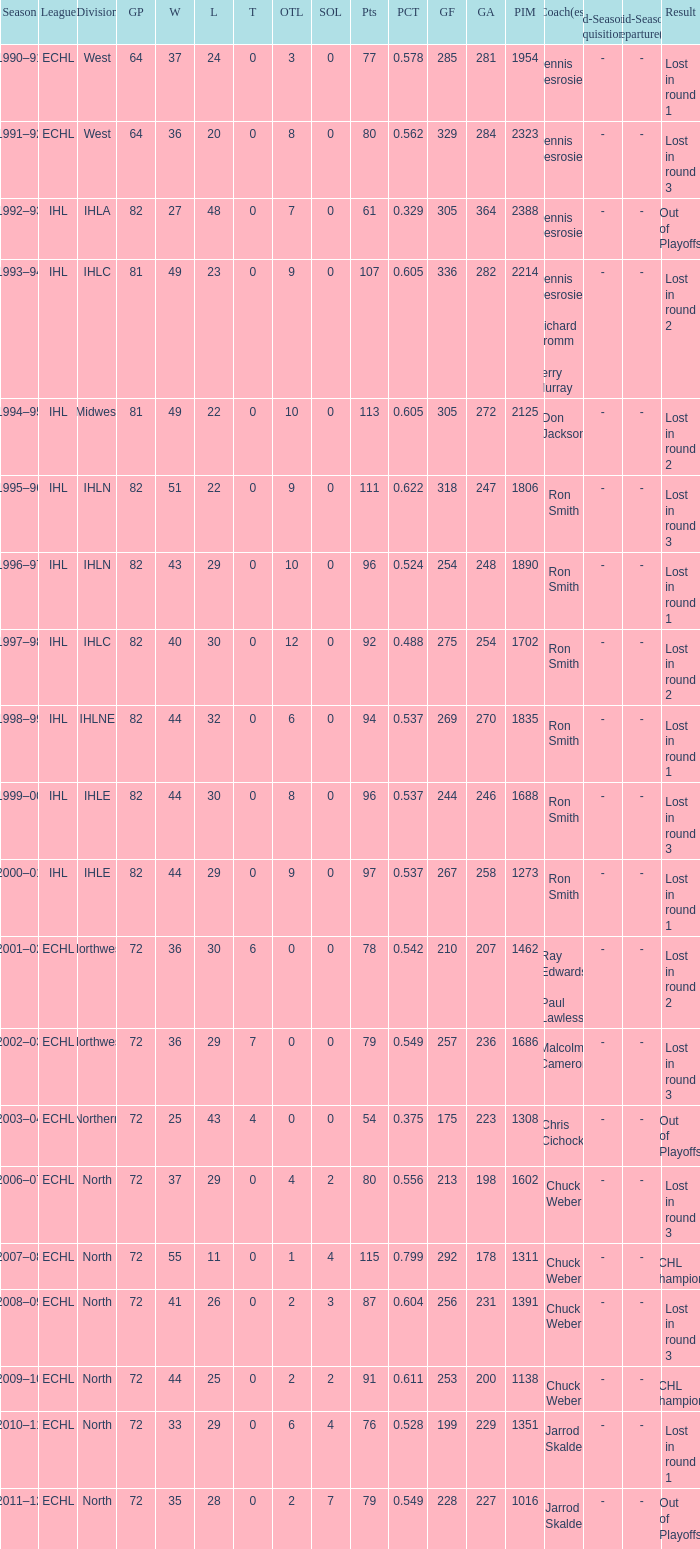What is the smallest l value if the arithmetic mean is 272? 22.0. 